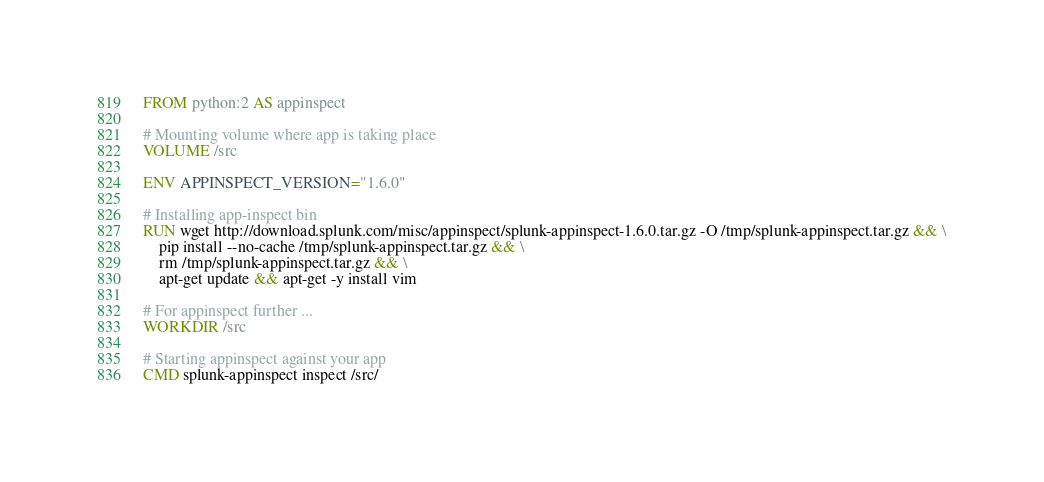Convert code to text. <code><loc_0><loc_0><loc_500><loc_500><_Dockerfile_>FROM python:2 AS appinspect

# Mounting volume where app is taking place
VOLUME /src

ENV APPINSPECT_VERSION="1.6.0"

# Installing app-inspect bin
RUN wget http://download.splunk.com/misc/appinspect/splunk-appinspect-1.6.0.tar.gz -O /tmp/splunk-appinspect.tar.gz && \
    pip install --no-cache /tmp/splunk-appinspect.tar.gz && \
    rm /tmp/splunk-appinspect.tar.gz && \
    apt-get update && apt-get -y install vim

# For appinspect further ... 
WORKDIR /src

# Starting appinspect against your app
CMD splunk-appinspect inspect /src/
</code> 